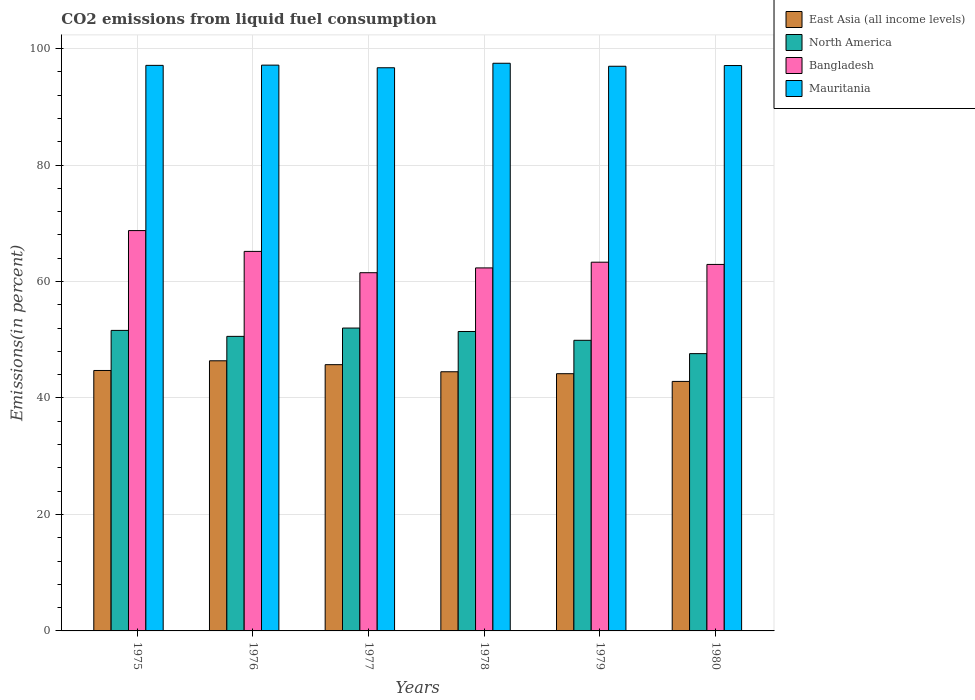How many bars are there on the 2nd tick from the left?
Your answer should be compact. 4. What is the total CO2 emitted in Mauritania in 1976?
Offer a very short reply. 97.16. Across all years, what is the maximum total CO2 emitted in East Asia (all income levels)?
Your answer should be compact. 46.39. Across all years, what is the minimum total CO2 emitted in North America?
Offer a terse response. 47.62. In which year was the total CO2 emitted in Mauritania maximum?
Give a very brief answer. 1978. In which year was the total CO2 emitted in East Asia (all income levels) minimum?
Provide a short and direct response. 1980. What is the total total CO2 emitted in North America in the graph?
Your answer should be very brief. 303.15. What is the difference between the total CO2 emitted in Mauritania in 1976 and that in 1979?
Keep it short and to the point. 0.19. What is the difference between the total CO2 emitted in East Asia (all income levels) in 1977 and the total CO2 emitted in North America in 1979?
Your response must be concise. -4.18. What is the average total CO2 emitted in North America per year?
Offer a terse response. 50.53. In the year 1976, what is the difference between the total CO2 emitted in East Asia (all income levels) and total CO2 emitted in Bangladesh?
Offer a very short reply. -18.79. In how many years, is the total CO2 emitted in Bangladesh greater than 92 %?
Give a very brief answer. 0. What is the ratio of the total CO2 emitted in North America in 1977 to that in 1979?
Offer a very short reply. 1.04. What is the difference between the highest and the second highest total CO2 emitted in Mauritania?
Give a very brief answer. 0.32. What is the difference between the highest and the lowest total CO2 emitted in Mauritania?
Provide a short and direct response. 0.77. In how many years, is the total CO2 emitted in North America greater than the average total CO2 emitted in North America taken over all years?
Keep it short and to the point. 4. What does the 1st bar from the left in 1976 represents?
Make the answer very short. East Asia (all income levels). What does the 2nd bar from the right in 1977 represents?
Offer a very short reply. Bangladesh. Are all the bars in the graph horizontal?
Offer a terse response. No. How many years are there in the graph?
Ensure brevity in your answer.  6. What is the difference between two consecutive major ticks on the Y-axis?
Keep it short and to the point. 20. Are the values on the major ticks of Y-axis written in scientific E-notation?
Ensure brevity in your answer.  No. Does the graph contain any zero values?
Ensure brevity in your answer.  No. Where does the legend appear in the graph?
Your answer should be very brief. Top right. How many legend labels are there?
Ensure brevity in your answer.  4. What is the title of the graph?
Give a very brief answer. CO2 emissions from liquid fuel consumption. What is the label or title of the X-axis?
Provide a succinct answer. Years. What is the label or title of the Y-axis?
Offer a very short reply. Emissions(in percent). What is the Emissions(in percent) of East Asia (all income levels) in 1975?
Your response must be concise. 44.73. What is the Emissions(in percent) in North America in 1975?
Your answer should be very brief. 51.61. What is the Emissions(in percent) of Bangladesh in 1975?
Ensure brevity in your answer.  68.75. What is the Emissions(in percent) of Mauritania in 1975?
Ensure brevity in your answer.  97.12. What is the Emissions(in percent) of East Asia (all income levels) in 1976?
Your answer should be very brief. 46.39. What is the Emissions(in percent) of North America in 1976?
Your answer should be very brief. 50.58. What is the Emissions(in percent) in Bangladesh in 1976?
Provide a short and direct response. 65.17. What is the Emissions(in percent) in Mauritania in 1976?
Your response must be concise. 97.16. What is the Emissions(in percent) in East Asia (all income levels) in 1977?
Provide a succinct answer. 45.72. What is the Emissions(in percent) of North America in 1977?
Ensure brevity in your answer.  52.01. What is the Emissions(in percent) in Bangladesh in 1977?
Your answer should be very brief. 61.51. What is the Emissions(in percent) of Mauritania in 1977?
Provide a short and direct response. 96.71. What is the Emissions(in percent) in East Asia (all income levels) in 1978?
Your answer should be very brief. 44.51. What is the Emissions(in percent) in North America in 1978?
Provide a short and direct response. 51.42. What is the Emissions(in percent) in Bangladesh in 1978?
Provide a succinct answer. 62.34. What is the Emissions(in percent) of Mauritania in 1978?
Provide a short and direct response. 97.48. What is the Emissions(in percent) of East Asia (all income levels) in 1979?
Ensure brevity in your answer.  44.17. What is the Emissions(in percent) in North America in 1979?
Offer a very short reply. 49.91. What is the Emissions(in percent) of Bangladesh in 1979?
Make the answer very short. 63.32. What is the Emissions(in percent) of Mauritania in 1979?
Offer a very short reply. 96.97. What is the Emissions(in percent) in East Asia (all income levels) in 1980?
Provide a succinct answer. 42.85. What is the Emissions(in percent) of North America in 1980?
Provide a succinct answer. 47.62. What is the Emissions(in percent) in Bangladesh in 1980?
Offer a very short reply. 62.94. What is the Emissions(in percent) of Mauritania in 1980?
Give a very brief answer. 97.09. Across all years, what is the maximum Emissions(in percent) in East Asia (all income levels)?
Your answer should be very brief. 46.39. Across all years, what is the maximum Emissions(in percent) in North America?
Offer a terse response. 52.01. Across all years, what is the maximum Emissions(in percent) of Bangladesh?
Your answer should be compact. 68.75. Across all years, what is the maximum Emissions(in percent) in Mauritania?
Make the answer very short. 97.48. Across all years, what is the minimum Emissions(in percent) of East Asia (all income levels)?
Make the answer very short. 42.85. Across all years, what is the minimum Emissions(in percent) of North America?
Your answer should be compact. 47.62. Across all years, what is the minimum Emissions(in percent) of Bangladesh?
Offer a terse response. 61.51. Across all years, what is the minimum Emissions(in percent) in Mauritania?
Give a very brief answer. 96.71. What is the total Emissions(in percent) of East Asia (all income levels) in the graph?
Provide a succinct answer. 268.37. What is the total Emissions(in percent) of North America in the graph?
Provide a short and direct response. 303.15. What is the total Emissions(in percent) in Bangladesh in the graph?
Your answer should be compact. 384.04. What is the total Emissions(in percent) in Mauritania in the graph?
Your response must be concise. 582.54. What is the difference between the Emissions(in percent) in East Asia (all income levels) in 1975 and that in 1976?
Offer a very short reply. -1.66. What is the difference between the Emissions(in percent) in Bangladesh in 1975 and that in 1976?
Your answer should be compact. 3.58. What is the difference between the Emissions(in percent) in Mauritania in 1975 and that in 1976?
Ensure brevity in your answer.  -0.04. What is the difference between the Emissions(in percent) in East Asia (all income levels) in 1975 and that in 1977?
Your answer should be compact. -1. What is the difference between the Emissions(in percent) in North America in 1975 and that in 1977?
Ensure brevity in your answer.  -0.4. What is the difference between the Emissions(in percent) in Bangladesh in 1975 and that in 1977?
Your response must be concise. 7.24. What is the difference between the Emissions(in percent) in Mauritania in 1975 and that in 1977?
Ensure brevity in your answer.  0.41. What is the difference between the Emissions(in percent) in East Asia (all income levels) in 1975 and that in 1978?
Offer a very short reply. 0.22. What is the difference between the Emissions(in percent) of North America in 1975 and that in 1978?
Offer a terse response. 0.19. What is the difference between the Emissions(in percent) in Bangladesh in 1975 and that in 1978?
Your response must be concise. 6.41. What is the difference between the Emissions(in percent) of Mauritania in 1975 and that in 1978?
Provide a succinct answer. -0.36. What is the difference between the Emissions(in percent) of East Asia (all income levels) in 1975 and that in 1979?
Ensure brevity in your answer.  0.55. What is the difference between the Emissions(in percent) in North America in 1975 and that in 1979?
Offer a terse response. 1.7. What is the difference between the Emissions(in percent) in Bangladesh in 1975 and that in 1979?
Your answer should be very brief. 5.43. What is the difference between the Emissions(in percent) in Mauritania in 1975 and that in 1979?
Provide a succinct answer. 0.15. What is the difference between the Emissions(in percent) in East Asia (all income levels) in 1975 and that in 1980?
Ensure brevity in your answer.  1.88. What is the difference between the Emissions(in percent) of North America in 1975 and that in 1980?
Your answer should be compact. 3.99. What is the difference between the Emissions(in percent) in Bangladesh in 1975 and that in 1980?
Give a very brief answer. 5.81. What is the difference between the Emissions(in percent) in Mauritania in 1975 and that in 1980?
Keep it short and to the point. 0.03. What is the difference between the Emissions(in percent) in East Asia (all income levels) in 1976 and that in 1977?
Your response must be concise. 0.66. What is the difference between the Emissions(in percent) of North America in 1976 and that in 1977?
Make the answer very short. -1.43. What is the difference between the Emissions(in percent) of Bangladesh in 1976 and that in 1977?
Provide a succinct answer. 3.66. What is the difference between the Emissions(in percent) in Mauritania in 1976 and that in 1977?
Make the answer very short. 0.45. What is the difference between the Emissions(in percent) of East Asia (all income levels) in 1976 and that in 1978?
Your response must be concise. 1.88. What is the difference between the Emissions(in percent) of North America in 1976 and that in 1978?
Your response must be concise. -0.84. What is the difference between the Emissions(in percent) in Bangladesh in 1976 and that in 1978?
Keep it short and to the point. 2.83. What is the difference between the Emissions(in percent) in Mauritania in 1976 and that in 1978?
Make the answer very short. -0.32. What is the difference between the Emissions(in percent) in East Asia (all income levels) in 1976 and that in 1979?
Ensure brevity in your answer.  2.21. What is the difference between the Emissions(in percent) in North America in 1976 and that in 1979?
Your answer should be very brief. 0.68. What is the difference between the Emissions(in percent) in Bangladesh in 1976 and that in 1979?
Make the answer very short. 1.85. What is the difference between the Emissions(in percent) of Mauritania in 1976 and that in 1979?
Your answer should be very brief. 0.19. What is the difference between the Emissions(in percent) of East Asia (all income levels) in 1976 and that in 1980?
Give a very brief answer. 3.54. What is the difference between the Emissions(in percent) of North America in 1976 and that in 1980?
Keep it short and to the point. 2.96. What is the difference between the Emissions(in percent) of Bangladesh in 1976 and that in 1980?
Make the answer very short. 2.24. What is the difference between the Emissions(in percent) of Mauritania in 1976 and that in 1980?
Offer a terse response. 0.07. What is the difference between the Emissions(in percent) of East Asia (all income levels) in 1977 and that in 1978?
Your response must be concise. 1.22. What is the difference between the Emissions(in percent) of North America in 1977 and that in 1978?
Offer a terse response. 0.59. What is the difference between the Emissions(in percent) of Bangladesh in 1977 and that in 1978?
Your response must be concise. -0.83. What is the difference between the Emissions(in percent) of Mauritania in 1977 and that in 1978?
Keep it short and to the point. -0.77. What is the difference between the Emissions(in percent) of East Asia (all income levels) in 1977 and that in 1979?
Your answer should be compact. 1.55. What is the difference between the Emissions(in percent) of North America in 1977 and that in 1979?
Ensure brevity in your answer.  2.1. What is the difference between the Emissions(in percent) in Bangladesh in 1977 and that in 1979?
Offer a very short reply. -1.81. What is the difference between the Emissions(in percent) of Mauritania in 1977 and that in 1979?
Offer a terse response. -0.26. What is the difference between the Emissions(in percent) of East Asia (all income levels) in 1977 and that in 1980?
Give a very brief answer. 2.88. What is the difference between the Emissions(in percent) in North America in 1977 and that in 1980?
Provide a succinct answer. 4.39. What is the difference between the Emissions(in percent) in Bangladesh in 1977 and that in 1980?
Your response must be concise. -1.42. What is the difference between the Emissions(in percent) of Mauritania in 1977 and that in 1980?
Your answer should be very brief. -0.38. What is the difference between the Emissions(in percent) in East Asia (all income levels) in 1978 and that in 1979?
Ensure brevity in your answer.  0.33. What is the difference between the Emissions(in percent) in North America in 1978 and that in 1979?
Make the answer very short. 1.51. What is the difference between the Emissions(in percent) in Bangladesh in 1978 and that in 1979?
Keep it short and to the point. -0.98. What is the difference between the Emissions(in percent) of Mauritania in 1978 and that in 1979?
Provide a short and direct response. 0.51. What is the difference between the Emissions(in percent) of East Asia (all income levels) in 1978 and that in 1980?
Offer a very short reply. 1.66. What is the difference between the Emissions(in percent) in North America in 1978 and that in 1980?
Offer a terse response. 3.8. What is the difference between the Emissions(in percent) in Bangladesh in 1978 and that in 1980?
Offer a terse response. -0.6. What is the difference between the Emissions(in percent) in Mauritania in 1978 and that in 1980?
Provide a succinct answer. 0.39. What is the difference between the Emissions(in percent) in East Asia (all income levels) in 1979 and that in 1980?
Give a very brief answer. 1.33. What is the difference between the Emissions(in percent) of North America in 1979 and that in 1980?
Give a very brief answer. 2.29. What is the difference between the Emissions(in percent) in Bangladesh in 1979 and that in 1980?
Provide a succinct answer. 0.38. What is the difference between the Emissions(in percent) in Mauritania in 1979 and that in 1980?
Ensure brevity in your answer.  -0.12. What is the difference between the Emissions(in percent) in East Asia (all income levels) in 1975 and the Emissions(in percent) in North America in 1976?
Your answer should be very brief. -5.86. What is the difference between the Emissions(in percent) of East Asia (all income levels) in 1975 and the Emissions(in percent) of Bangladesh in 1976?
Offer a terse response. -20.45. What is the difference between the Emissions(in percent) in East Asia (all income levels) in 1975 and the Emissions(in percent) in Mauritania in 1976?
Your answer should be very brief. -52.44. What is the difference between the Emissions(in percent) in North America in 1975 and the Emissions(in percent) in Bangladesh in 1976?
Keep it short and to the point. -13.57. What is the difference between the Emissions(in percent) in North America in 1975 and the Emissions(in percent) in Mauritania in 1976?
Make the answer very short. -45.56. What is the difference between the Emissions(in percent) of Bangladesh in 1975 and the Emissions(in percent) of Mauritania in 1976?
Offer a very short reply. -28.41. What is the difference between the Emissions(in percent) of East Asia (all income levels) in 1975 and the Emissions(in percent) of North America in 1977?
Offer a very short reply. -7.29. What is the difference between the Emissions(in percent) in East Asia (all income levels) in 1975 and the Emissions(in percent) in Bangladesh in 1977?
Give a very brief answer. -16.79. What is the difference between the Emissions(in percent) of East Asia (all income levels) in 1975 and the Emissions(in percent) of Mauritania in 1977?
Ensure brevity in your answer.  -51.98. What is the difference between the Emissions(in percent) in North America in 1975 and the Emissions(in percent) in Bangladesh in 1977?
Offer a terse response. -9.91. What is the difference between the Emissions(in percent) of North America in 1975 and the Emissions(in percent) of Mauritania in 1977?
Ensure brevity in your answer.  -45.1. What is the difference between the Emissions(in percent) in Bangladesh in 1975 and the Emissions(in percent) in Mauritania in 1977?
Offer a very short reply. -27.96. What is the difference between the Emissions(in percent) in East Asia (all income levels) in 1975 and the Emissions(in percent) in North America in 1978?
Your answer should be very brief. -6.7. What is the difference between the Emissions(in percent) of East Asia (all income levels) in 1975 and the Emissions(in percent) of Bangladesh in 1978?
Your answer should be very brief. -17.61. What is the difference between the Emissions(in percent) of East Asia (all income levels) in 1975 and the Emissions(in percent) of Mauritania in 1978?
Provide a succinct answer. -52.76. What is the difference between the Emissions(in percent) of North America in 1975 and the Emissions(in percent) of Bangladesh in 1978?
Ensure brevity in your answer.  -10.73. What is the difference between the Emissions(in percent) in North America in 1975 and the Emissions(in percent) in Mauritania in 1978?
Your answer should be very brief. -45.88. What is the difference between the Emissions(in percent) of Bangladesh in 1975 and the Emissions(in percent) of Mauritania in 1978?
Provide a short and direct response. -28.73. What is the difference between the Emissions(in percent) in East Asia (all income levels) in 1975 and the Emissions(in percent) in North America in 1979?
Provide a succinct answer. -5.18. What is the difference between the Emissions(in percent) in East Asia (all income levels) in 1975 and the Emissions(in percent) in Bangladesh in 1979?
Provide a succinct answer. -18.59. What is the difference between the Emissions(in percent) of East Asia (all income levels) in 1975 and the Emissions(in percent) of Mauritania in 1979?
Your response must be concise. -52.24. What is the difference between the Emissions(in percent) of North America in 1975 and the Emissions(in percent) of Bangladesh in 1979?
Your answer should be very brief. -11.71. What is the difference between the Emissions(in percent) of North America in 1975 and the Emissions(in percent) of Mauritania in 1979?
Offer a terse response. -45.36. What is the difference between the Emissions(in percent) in Bangladesh in 1975 and the Emissions(in percent) in Mauritania in 1979?
Your answer should be very brief. -28.22. What is the difference between the Emissions(in percent) of East Asia (all income levels) in 1975 and the Emissions(in percent) of North America in 1980?
Keep it short and to the point. -2.89. What is the difference between the Emissions(in percent) in East Asia (all income levels) in 1975 and the Emissions(in percent) in Bangladesh in 1980?
Offer a terse response. -18.21. What is the difference between the Emissions(in percent) of East Asia (all income levels) in 1975 and the Emissions(in percent) of Mauritania in 1980?
Keep it short and to the point. -52.37. What is the difference between the Emissions(in percent) in North America in 1975 and the Emissions(in percent) in Bangladesh in 1980?
Your answer should be very brief. -11.33. What is the difference between the Emissions(in percent) in North America in 1975 and the Emissions(in percent) in Mauritania in 1980?
Give a very brief answer. -45.49. What is the difference between the Emissions(in percent) in Bangladesh in 1975 and the Emissions(in percent) in Mauritania in 1980?
Ensure brevity in your answer.  -28.34. What is the difference between the Emissions(in percent) in East Asia (all income levels) in 1976 and the Emissions(in percent) in North America in 1977?
Keep it short and to the point. -5.62. What is the difference between the Emissions(in percent) in East Asia (all income levels) in 1976 and the Emissions(in percent) in Bangladesh in 1977?
Provide a short and direct response. -15.13. What is the difference between the Emissions(in percent) of East Asia (all income levels) in 1976 and the Emissions(in percent) of Mauritania in 1977?
Make the answer very short. -50.32. What is the difference between the Emissions(in percent) of North America in 1976 and the Emissions(in percent) of Bangladesh in 1977?
Give a very brief answer. -10.93. What is the difference between the Emissions(in percent) in North America in 1976 and the Emissions(in percent) in Mauritania in 1977?
Offer a very short reply. -46.13. What is the difference between the Emissions(in percent) in Bangladesh in 1976 and the Emissions(in percent) in Mauritania in 1977?
Ensure brevity in your answer.  -31.54. What is the difference between the Emissions(in percent) in East Asia (all income levels) in 1976 and the Emissions(in percent) in North America in 1978?
Keep it short and to the point. -5.03. What is the difference between the Emissions(in percent) of East Asia (all income levels) in 1976 and the Emissions(in percent) of Bangladesh in 1978?
Offer a very short reply. -15.95. What is the difference between the Emissions(in percent) of East Asia (all income levels) in 1976 and the Emissions(in percent) of Mauritania in 1978?
Offer a terse response. -51.1. What is the difference between the Emissions(in percent) of North America in 1976 and the Emissions(in percent) of Bangladesh in 1978?
Offer a terse response. -11.76. What is the difference between the Emissions(in percent) in North America in 1976 and the Emissions(in percent) in Mauritania in 1978?
Your answer should be very brief. -46.9. What is the difference between the Emissions(in percent) of Bangladesh in 1976 and the Emissions(in percent) of Mauritania in 1978?
Give a very brief answer. -32.31. What is the difference between the Emissions(in percent) of East Asia (all income levels) in 1976 and the Emissions(in percent) of North America in 1979?
Your answer should be compact. -3.52. What is the difference between the Emissions(in percent) of East Asia (all income levels) in 1976 and the Emissions(in percent) of Bangladesh in 1979?
Ensure brevity in your answer.  -16.93. What is the difference between the Emissions(in percent) of East Asia (all income levels) in 1976 and the Emissions(in percent) of Mauritania in 1979?
Your answer should be very brief. -50.58. What is the difference between the Emissions(in percent) of North America in 1976 and the Emissions(in percent) of Bangladesh in 1979?
Make the answer very short. -12.74. What is the difference between the Emissions(in percent) in North America in 1976 and the Emissions(in percent) in Mauritania in 1979?
Your answer should be very brief. -46.39. What is the difference between the Emissions(in percent) in Bangladesh in 1976 and the Emissions(in percent) in Mauritania in 1979?
Your answer should be compact. -31.8. What is the difference between the Emissions(in percent) of East Asia (all income levels) in 1976 and the Emissions(in percent) of North America in 1980?
Your answer should be very brief. -1.23. What is the difference between the Emissions(in percent) of East Asia (all income levels) in 1976 and the Emissions(in percent) of Bangladesh in 1980?
Offer a terse response. -16.55. What is the difference between the Emissions(in percent) of East Asia (all income levels) in 1976 and the Emissions(in percent) of Mauritania in 1980?
Keep it short and to the point. -50.7. What is the difference between the Emissions(in percent) in North America in 1976 and the Emissions(in percent) in Bangladesh in 1980?
Your answer should be very brief. -12.35. What is the difference between the Emissions(in percent) of North America in 1976 and the Emissions(in percent) of Mauritania in 1980?
Offer a very short reply. -46.51. What is the difference between the Emissions(in percent) in Bangladesh in 1976 and the Emissions(in percent) in Mauritania in 1980?
Ensure brevity in your answer.  -31.92. What is the difference between the Emissions(in percent) in East Asia (all income levels) in 1977 and the Emissions(in percent) in North America in 1978?
Offer a very short reply. -5.7. What is the difference between the Emissions(in percent) in East Asia (all income levels) in 1977 and the Emissions(in percent) in Bangladesh in 1978?
Give a very brief answer. -16.62. What is the difference between the Emissions(in percent) of East Asia (all income levels) in 1977 and the Emissions(in percent) of Mauritania in 1978?
Your answer should be compact. -51.76. What is the difference between the Emissions(in percent) of North America in 1977 and the Emissions(in percent) of Bangladesh in 1978?
Provide a short and direct response. -10.33. What is the difference between the Emissions(in percent) of North America in 1977 and the Emissions(in percent) of Mauritania in 1978?
Your response must be concise. -45.47. What is the difference between the Emissions(in percent) of Bangladesh in 1977 and the Emissions(in percent) of Mauritania in 1978?
Your answer should be compact. -35.97. What is the difference between the Emissions(in percent) in East Asia (all income levels) in 1977 and the Emissions(in percent) in North America in 1979?
Keep it short and to the point. -4.18. What is the difference between the Emissions(in percent) in East Asia (all income levels) in 1977 and the Emissions(in percent) in Bangladesh in 1979?
Your response must be concise. -17.6. What is the difference between the Emissions(in percent) in East Asia (all income levels) in 1977 and the Emissions(in percent) in Mauritania in 1979?
Your response must be concise. -51.24. What is the difference between the Emissions(in percent) in North America in 1977 and the Emissions(in percent) in Bangladesh in 1979?
Keep it short and to the point. -11.31. What is the difference between the Emissions(in percent) of North America in 1977 and the Emissions(in percent) of Mauritania in 1979?
Make the answer very short. -44.96. What is the difference between the Emissions(in percent) in Bangladesh in 1977 and the Emissions(in percent) in Mauritania in 1979?
Offer a very short reply. -35.46. What is the difference between the Emissions(in percent) in East Asia (all income levels) in 1977 and the Emissions(in percent) in North America in 1980?
Your response must be concise. -1.89. What is the difference between the Emissions(in percent) of East Asia (all income levels) in 1977 and the Emissions(in percent) of Bangladesh in 1980?
Keep it short and to the point. -17.21. What is the difference between the Emissions(in percent) in East Asia (all income levels) in 1977 and the Emissions(in percent) in Mauritania in 1980?
Your answer should be very brief. -51.37. What is the difference between the Emissions(in percent) of North America in 1977 and the Emissions(in percent) of Bangladesh in 1980?
Provide a succinct answer. -10.93. What is the difference between the Emissions(in percent) of North America in 1977 and the Emissions(in percent) of Mauritania in 1980?
Offer a terse response. -45.08. What is the difference between the Emissions(in percent) of Bangladesh in 1977 and the Emissions(in percent) of Mauritania in 1980?
Offer a very short reply. -35.58. What is the difference between the Emissions(in percent) in East Asia (all income levels) in 1978 and the Emissions(in percent) in North America in 1979?
Offer a terse response. -5.4. What is the difference between the Emissions(in percent) of East Asia (all income levels) in 1978 and the Emissions(in percent) of Bangladesh in 1979?
Offer a terse response. -18.81. What is the difference between the Emissions(in percent) of East Asia (all income levels) in 1978 and the Emissions(in percent) of Mauritania in 1979?
Your response must be concise. -52.46. What is the difference between the Emissions(in percent) of North America in 1978 and the Emissions(in percent) of Bangladesh in 1979?
Ensure brevity in your answer.  -11.9. What is the difference between the Emissions(in percent) of North America in 1978 and the Emissions(in percent) of Mauritania in 1979?
Ensure brevity in your answer.  -45.55. What is the difference between the Emissions(in percent) in Bangladesh in 1978 and the Emissions(in percent) in Mauritania in 1979?
Make the answer very short. -34.63. What is the difference between the Emissions(in percent) of East Asia (all income levels) in 1978 and the Emissions(in percent) of North America in 1980?
Offer a terse response. -3.11. What is the difference between the Emissions(in percent) of East Asia (all income levels) in 1978 and the Emissions(in percent) of Bangladesh in 1980?
Your response must be concise. -18.43. What is the difference between the Emissions(in percent) in East Asia (all income levels) in 1978 and the Emissions(in percent) in Mauritania in 1980?
Your answer should be compact. -52.59. What is the difference between the Emissions(in percent) of North America in 1978 and the Emissions(in percent) of Bangladesh in 1980?
Your response must be concise. -11.52. What is the difference between the Emissions(in percent) of North America in 1978 and the Emissions(in percent) of Mauritania in 1980?
Keep it short and to the point. -45.67. What is the difference between the Emissions(in percent) of Bangladesh in 1978 and the Emissions(in percent) of Mauritania in 1980?
Ensure brevity in your answer.  -34.75. What is the difference between the Emissions(in percent) in East Asia (all income levels) in 1979 and the Emissions(in percent) in North America in 1980?
Provide a succinct answer. -3.45. What is the difference between the Emissions(in percent) in East Asia (all income levels) in 1979 and the Emissions(in percent) in Bangladesh in 1980?
Make the answer very short. -18.76. What is the difference between the Emissions(in percent) in East Asia (all income levels) in 1979 and the Emissions(in percent) in Mauritania in 1980?
Provide a short and direct response. -52.92. What is the difference between the Emissions(in percent) of North America in 1979 and the Emissions(in percent) of Bangladesh in 1980?
Your answer should be compact. -13.03. What is the difference between the Emissions(in percent) in North America in 1979 and the Emissions(in percent) in Mauritania in 1980?
Ensure brevity in your answer.  -47.18. What is the difference between the Emissions(in percent) in Bangladesh in 1979 and the Emissions(in percent) in Mauritania in 1980?
Offer a terse response. -33.77. What is the average Emissions(in percent) in East Asia (all income levels) per year?
Provide a succinct answer. 44.73. What is the average Emissions(in percent) in North America per year?
Provide a succinct answer. 50.53. What is the average Emissions(in percent) of Bangladesh per year?
Give a very brief answer. 64.01. What is the average Emissions(in percent) of Mauritania per year?
Make the answer very short. 97.09. In the year 1975, what is the difference between the Emissions(in percent) of East Asia (all income levels) and Emissions(in percent) of North America?
Make the answer very short. -6.88. In the year 1975, what is the difference between the Emissions(in percent) in East Asia (all income levels) and Emissions(in percent) in Bangladesh?
Make the answer very short. -24.02. In the year 1975, what is the difference between the Emissions(in percent) in East Asia (all income levels) and Emissions(in percent) in Mauritania?
Your response must be concise. -52.4. In the year 1975, what is the difference between the Emissions(in percent) in North America and Emissions(in percent) in Bangladesh?
Offer a very short reply. -17.14. In the year 1975, what is the difference between the Emissions(in percent) of North America and Emissions(in percent) of Mauritania?
Make the answer very short. -45.51. In the year 1975, what is the difference between the Emissions(in percent) in Bangladesh and Emissions(in percent) in Mauritania?
Keep it short and to the point. -28.37. In the year 1976, what is the difference between the Emissions(in percent) in East Asia (all income levels) and Emissions(in percent) in North America?
Your answer should be very brief. -4.2. In the year 1976, what is the difference between the Emissions(in percent) of East Asia (all income levels) and Emissions(in percent) of Bangladesh?
Give a very brief answer. -18.79. In the year 1976, what is the difference between the Emissions(in percent) in East Asia (all income levels) and Emissions(in percent) in Mauritania?
Your response must be concise. -50.77. In the year 1976, what is the difference between the Emissions(in percent) in North America and Emissions(in percent) in Bangladesh?
Your answer should be compact. -14.59. In the year 1976, what is the difference between the Emissions(in percent) of North America and Emissions(in percent) of Mauritania?
Your answer should be compact. -46.58. In the year 1976, what is the difference between the Emissions(in percent) in Bangladesh and Emissions(in percent) in Mauritania?
Offer a very short reply. -31.99. In the year 1977, what is the difference between the Emissions(in percent) of East Asia (all income levels) and Emissions(in percent) of North America?
Your answer should be compact. -6.29. In the year 1977, what is the difference between the Emissions(in percent) of East Asia (all income levels) and Emissions(in percent) of Bangladesh?
Your response must be concise. -15.79. In the year 1977, what is the difference between the Emissions(in percent) in East Asia (all income levels) and Emissions(in percent) in Mauritania?
Give a very brief answer. -50.99. In the year 1977, what is the difference between the Emissions(in percent) of North America and Emissions(in percent) of Bangladesh?
Your response must be concise. -9.5. In the year 1977, what is the difference between the Emissions(in percent) in North America and Emissions(in percent) in Mauritania?
Your answer should be very brief. -44.7. In the year 1977, what is the difference between the Emissions(in percent) in Bangladesh and Emissions(in percent) in Mauritania?
Make the answer very short. -35.2. In the year 1978, what is the difference between the Emissions(in percent) in East Asia (all income levels) and Emissions(in percent) in North America?
Offer a terse response. -6.92. In the year 1978, what is the difference between the Emissions(in percent) of East Asia (all income levels) and Emissions(in percent) of Bangladesh?
Keep it short and to the point. -17.83. In the year 1978, what is the difference between the Emissions(in percent) in East Asia (all income levels) and Emissions(in percent) in Mauritania?
Your answer should be very brief. -52.98. In the year 1978, what is the difference between the Emissions(in percent) in North America and Emissions(in percent) in Bangladesh?
Ensure brevity in your answer.  -10.92. In the year 1978, what is the difference between the Emissions(in percent) in North America and Emissions(in percent) in Mauritania?
Provide a succinct answer. -46.06. In the year 1978, what is the difference between the Emissions(in percent) of Bangladesh and Emissions(in percent) of Mauritania?
Ensure brevity in your answer.  -35.14. In the year 1979, what is the difference between the Emissions(in percent) of East Asia (all income levels) and Emissions(in percent) of North America?
Give a very brief answer. -5.73. In the year 1979, what is the difference between the Emissions(in percent) of East Asia (all income levels) and Emissions(in percent) of Bangladesh?
Provide a succinct answer. -19.15. In the year 1979, what is the difference between the Emissions(in percent) in East Asia (all income levels) and Emissions(in percent) in Mauritania?
Your answer should be very brief. -52.8. In the year 1979, what is the difference between the Emissions(in percent) in North America and Emissions(in percent) in Bangladesh?
Ensure brevity in your answer.  -13.41. In the year 1979, what is the difference between the Emissions(in percent) in North America and Emissions(in percent) in Mauritania?
Your response must be concise. -47.06. In the year 1979, what is the difference between the Emissions(in percent) of Bangladesh and Emissions(in percent) of Mauritania?
Keep it short and to the point. -33.65. In the year 1980, what is the difference between the Emissions(in percent) in East Asia (all income levels) and Emissions(in percent) in North America?
Make the answer very short. -4.77. In the year 1980, what is the difference between the Emissions(in percent) in East Asia (all income levels) and Emissions(in percent) in Bangladesh?
Your answer should be compact. -20.09. In the year 1980, what is the difference between the Emissions(in percent) in East Asia (all income levels) and Emissions(in percent) in Mauritania?
Provide a short and direct response. -54.25. In the year 1980, what is the difference between the Emissions(in percent) of North America and Emissions(in percent) of Bangladesh?
Your response must be concise. -15.32. In the year 1980, what is the difference between the Emissions(in percent) of North America and Emissions(in percent) of Mauritania?
Provide a succinct answer. -49.47. In the year 1980, what is the difference between the Emissions(in percent) in Bangladesh and Emissions(in percent) in Mauritania?
Keep it short and to the point. -34.16. What is the ratio of the Emissions(in percent) of East Asia (all income levels) in 1975 to that in 1976?
Provide a short and direct response. 0.96. What is the ratio of the Emissions(in percent) in North America in 1975 to that in 1976?
Offer a terse response. 1.02. What is the ratio of the Emissions(in percent) in Bangladesh in 1975 to that in 1976?
Give a very brief answer. 1.05. What is the ratio of the Emissions(in percent) in East Asia (all income levels) in 1975 to that in 1977?
Make the answer very short. 0.98. What is the ratio of the Emissions(in percent) of Bangladesh in 1975 to that in 1977?
Make the answer very short. 1.12. What is the ratio of the Emissions(in percent) in Mauritania in 1975 to that in 1977?
Keep it short and to the point. 1. What is the ratio of the Emissions(in percent) in East Asia (all income levels) in 1975 to that in 1978?
Offer a very short reply. 1. What is the ratio of the Emissions(in percent) of North America in 1975 to that in 1978?
Offer a very short reply. 1. What is the ratio of the Emissions(in percent) of Bangladesh in 1975 to that in 1978?
Provide a short and direct response. 1.1. What is the ratio of the Emissions(in percent) of East Asia (all income levels) in 1975 to that in 1979?
Offer a terse response. 1.01. What is the ratio of the Emissions(in percent) in North America in 1975 to that in 1979?
Offer a very short reply. 1.03. What is the ratio of the Emissions(in percent) in Bangladesh in 1975 to that in 1979?
Make the answer very short. 1.09. What is the ratio of the Emissions(in percent) in Mauritania in 1975 to that in 1979?
Offer a very short reply. 1. What is the ratio of the Emissions(in percent) of East Asia (all income levels) in 1975 to that in 1980?
Offer a terse response. 1.04. What is the ratio of the Emissions(in percent) in North America in 1975 to that in 1980?
Give a very brief answer. 1.08. What is the ratio of the Emissions(in percent) of Bangladesh in 1975 to that in 1980?
Ensure brevity in your answer.  1.09. What is the ratio of the Emissions(in percent) in East Asia (all income levels) in 1976 to that in 1977?
Ensure brevity in your answer.  1.01. What is the ratio of the Emissions(in percent) in North America in 1976 to that in 1977?
Your answer should be very brief. 0.97. What is the ratio of the Emissions(in percent) in Bangladesh in 1976 to that in 1977?
Offer a terse response. 1.06. What is the ratio of the Emissions(in percent) in Mauritania in 1976 to that in 1977?
Make the answer very short. 1. What is the ratio of the Emissions(in percent) of East Asia (all income levels) in 1976 to that in 1978?
Offer a very short reply. 1.04. What is the ratio of the Emissions(in percent) of North America in 1976 to that in 1978?
Provide a short and direct response. 0.98. What is the ratio of the Emissions(in percent) in Bangladesh in 1976 to that in 1978?
Make the answer very short. 1.05. What is the ratio of the Emissions(in percent) in Mauritania in 1976 to that in 1978?
Keep it short and to the point. 1. What is the ratio of the Emissions(in percent) of East Asia (all income levels) in 1976 to that in 1979?
Make the answer very short. 1.05. What is the ratio of the Emissions(in percent) in North America in 1976 to that in 1979?
Your answer should be compact. 1.01. What is the ratio of the Emissions(in percent) in Bangladesh in 1976 to that in 1979?
Keep it short and to the point. 1.03. What is the ratio of the Emissions(in percent) in East Asia (all income levels) in 1976 to that in 1980?
Your response must be concise. 1.08. What is the ratio of the Emissions(in percent) of North America in 1976 to that in 1980?
Give a very brief answer. 1.06. What is the ratio of the Emissions(in percent) of Bangladesh in 1976 to that in 1980?
Make the answer very short. 1.04. What is the ratio of the Emissions(in percent) in Mauritania in 1976 to that in 1980?
Keep it short and to the point. 1. What is the ratio of the Emissions(in percent) in East Asia (all income levels) in 1977 to that in 1978?
Provide a succinct answer. 1.03. What is the ratio of the Emissions(in percent) in North America in 1977 to that in 1978?
Your answer should be very brief. 1.01. What is the ratio of the Emissions(in percent) of Mauritania in 1977 to that in 1978?
Offer a terse response. 0.99. What is the ratio of the Emissions(in percent) of East Asia (all income levels) in 1977 to that in 1979?
Provide a succinct answer. 1.04. What is the ratio of the Emissions(in percent) of North America in 1977 to that in 1979?
Keep it short and to the point. 1.04. What is the ratio of the Emissions(in percent) of Bangladesh in 1977 to that in 1979?
Offer a very short reply. 0.97. What is the ratio of the Emissions(in percent) of Mauritania in 1977 to that in 1979?
Make the answer very short. 1. What is the ratio of the Emissions(in percent) in East Asia (all income levels) in 1977 to that in 1980?
Your answer should be compact. 1.07. What is the ratio of the Emissions(in percent) in North America in 1977 to that in 1980?
Offer a very short reply. 1.09. What is the ratio of the Emissions(in percent) of Bangladesh in 1977 to that in 1980?
Ensure brevity in your answer.  0.98. What is the ratio of the Emissions(in percent) of East Asia (all income levels) in 1978 to that in 1979?
Keep it short and to the point. 1.01. What is the ratio of the Emissions(in percent) of North America in 1978 to that in 1979?
Give a very brief answer. 1.03. What is the ratio of the Emissions(in percent) of Bangladesh in 1978 to that in 1979?
Give a very brief answer. 0.98. What is the ratio of the Emissions(in percent) of East Asia (all income levels) in 1978 to that in 1980?
Offer a terse response. 1.04. What is the ratio of the Emissions(in percent) in North America in 1978 to that in 1980?
Your answer should be compact. 1.08. What is the ratio of the Emissions(in percent) of Bangladesh in 1978 to that in 1980?
Offer a very short reply. 0.99. What is the ratio of the Emissions(in percent) of East Asia (all income levels) in 1979 to that in 1980?
Your answer should be compact. 1.03. What is the ratio of the Emissions(in percent) of North America in 1979 to that in 1980?
Offer a terse response. 1.05. What is the ratio of the Emissions(in percent) in Bangladesh in 1979 to that in 1980?
Offer a terse response. 1.01. What is the ratio of the Emissions(in percent) in Mauritania in 1979 to that in 1980?
Your answer should be compact. 1. What is the difference between the highest and the second highest Emissions(in percent) in East Asia (all income levels)?
Offer a terse response. 0.66. What is the difference between the highest and the second highest Emissions(in percent) in North America?
Make the answer very short. 0.4. What is the difference between the highest and the second highest Emissions(in percent) in Bangladesh?
Provide a succinct answer. 3.58. What is the difference between the highest and the second highest Emissions(in percent) in Mauritania?
Offer a terse response. 0.32. What is the difference between the highest and the lowest Emissions(in percent) in East Asia (all income levels)?
Offer a terse response. 3.54. What is the difference between the highest and the lowest Emissions(in percent) of North America?
Your answer should be compact. 4.39. What is the difference between the highest and the lowest Emissions(in percent) of Bangladesh?
Offer a very short reply. 7.24. What is the difference between the highest and the lowest Emissions(in percent) in Mauritania?
Offer a terse response. 0.77. 